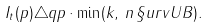Convert formula to latex. <formula><loc_0><loc_0><loc_500><loc_500>I _ { t } ( p ) \triangle q p \cdot \min ( k , \, n \, \S u r v U B ) .</formula> 